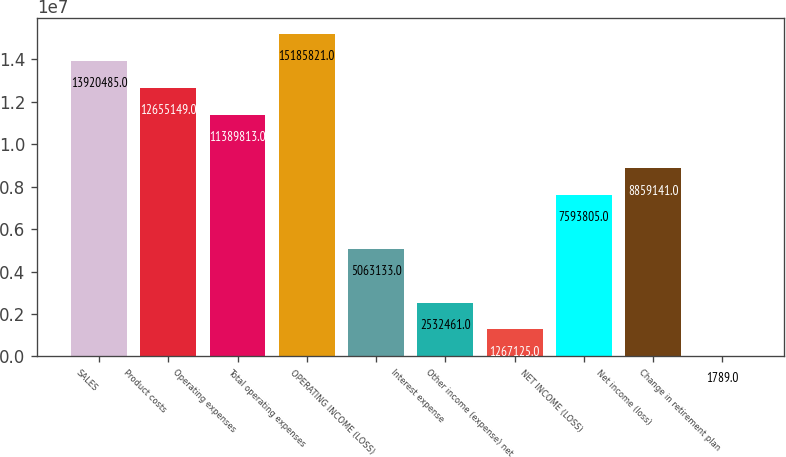Convert chart to OTSL. <chart><loc_0><loc_0><loc_500><loc_500><bar_chart><fcel>SALES<fcel>Product costs<fcel>Operating expenses<fcel>Total operating expenses<fcel>OPERATING INCOME (LOSS)<fcel>Interest expense<fcel>Other income (expense) net<fcel>NET INCOME (LOSS)<fcel>Net income (loss)<fcel>Change in retirement plan<nl><fcel>1.39205e+07<fcel>1.26551e+07<fcel>1.13898e+07<fcel>1.51858e+07<fcel>5.06313e+06<fcel>2.53246e+06<fcel>1.26712e+06<fcel>7.5938e+06<fcel>8.85914e+06<fcel>1789<nl></chart> 